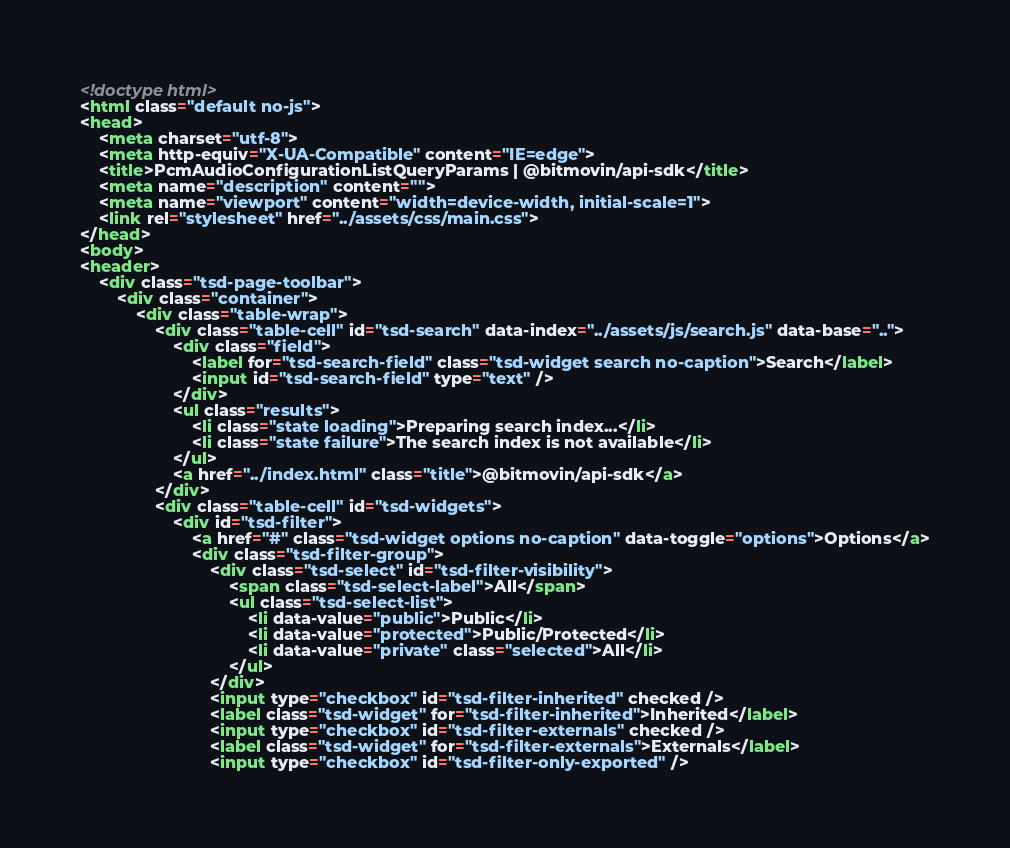<code> <loc_0><loc_0><loc_500><loc_500><_HTML_><!doctype html>
<html class="default no-js">
<head>
	<meta charset="utf-8">
	<meta http-equiv="X-UA-Compatible" content="IE=edge">
	<title>PcmAudioConfigurationListQueryParams | @bitmovin/api-sdk</title>
	<meta name="description" content="">
	<meta name="viewport" content="width=device-width, initial-scale=1">
	<link rel="stylesheet" href="../assets/css/main.css">
</head>
<body>
<header>
	<div class="tsd-page-toolbar">
		<div class="container">
			<div class="table-wrap">
				<div class="table-cell" id="tsd-search" data-index="../assets/js/search.js" data-base="..">
					<div class="field">
						<label for="tsd-search-field" class="tsd-widget search no-caption">Search</label>
						<input id="tsd-search-field" type="text" />
					</div>
					<ul class="results">
						<li class="state loading">Preparing search index...</li>
						<li class="state failure">The search index is not available</li>
					</ul>
					<a href="../index.html" class="title">@bitmovin/api-sdk</a>
				</div>
				<div class="table-cell" id="tsd-widgets">
					<div id="tsd-filter">
						<a href="#" class="tsd-widget options no-caption" data-toggle="options">Options</a>
						<div class="tsd-filter-group">
							<div class="tsd-select" id="tsd-filter-visibility">
								<span class="tsd-select-label">All</span>
								<ul class="tsd-select-list">
									<li data-value="public">Public</li>
									<li data-value="protected">Public/Protected</li>
									<li data-value="private" class="selected">All</li>
								</ul>
							</div>
							<input type="checkbox" id="tsd-filter-inherited" checked />
							<label class="tsd-widget" for="tsd-filter-inherited">Inherited</label>
							<input type="checkbox" id="tsd-filter-externals" checked />
							<label class="tsd-widget" for="tsd-filter-externals">Externals</label>
							<input type="checkbox" id="tsd-filter-only-exported" /></code> 